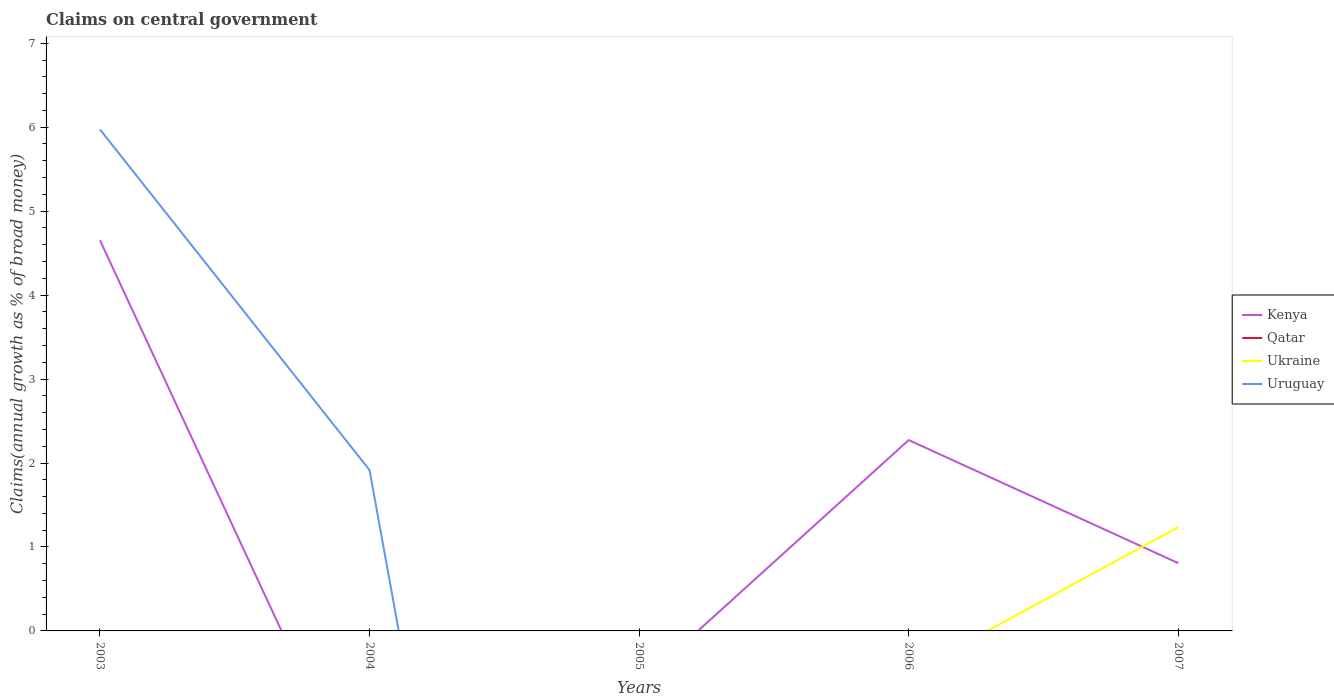How many different coloured lines are there?
Ensure brevity in your answer.  3. Does the line corresponding to Uruguay intersect with the line corresponding to Kenya?
Offer a very short reply. Yes. What is the difference between the highest and the second highest percentage of broad money claimed on centeral government in Uruguay?
Offer a very short reply. 5.97. Is the percentage of broad money claimed on centeral government in Ukraine strictly greater than the percentage of broad money claimed on centeral government in Qatar over the years?
Give a very brief answer. No. Are the values on the major ticks of Y-axis written in scientific E-notation?
Your response must be concise. No. Does the graph contain grids?
Your response must be concise. No. How many legend labels are there?
Your response must be concise. 4. What is the title of the graph?
Keep it short and to the point. Claims on central government. What is the label or title of the X-axis?
Provide a succinct answer. Years. What is the label or title of the Y-axis?
Offer a terse response. Claims(annual growth as % of broad money). What is the Claims(annual growth as % of broad money) in Kenya in 2003?
Make the answer very short. 4.65. What is the Claims(annual growth as % of broad money) of Uruguay in 2003?
Your answer should be compact. 5.97. What is the Claims(annual growth as % of broad money) in Ukraine in 2004?
Ensure brevity in your answer.  0. What is the Claims(annual growth as % of broad money) in Uruguay in 2004?
Give a very brief answer. 1.92. What is the Claims(annual growth as % of broad money) of Kenya in 2005?
Provide a short and direct response. 0. What is the Claims(annual growth as % of broad money) of Qatar in 2005?
Your response must be concise. 0. What is the Claims(annual growth as % of broad money) in Kenya in 2006?
Offer a very short reply. 2.27. What is the Claims(annual growth as % of broad money) in Kenya in 2007?
Your answer should be compact. 0.81. What is the Claims(annual growth as % of broad money) in Ukraine in 2007?
Make the answer very short. 1.24. What is the Claims(annual growth as % of broad money) in Uruguay in 2007?
Provide a short and direct response. 0. Across all years, what is the maximum Claims(annual growth as % of broad money) in Kenya?
Your answer should be compact. 4.65. Across all years, what is the maximum Claims(annual growth as % of broad money) in Ukraine?
Make the answer very short. 1.24. Across all years, what is the maximum Claims(annual growth as % of broad money) in Uruguay?
Your answer should be very brief. 5.97. Across all years, what is the minimum Claims(annual growth as % of broad money) in Kenya?
Offer a terse response. 0. Across all years, what is the minimum Claims(annual growth as % of broad money) of Ukraine?
Offer a terse response. 0. What is the total Claims(annual growth as % of broad money) in Kenya in the graph?
Offer a very short reply. 7.73. What is the total Claims(annual growth as % of broad money) in Qatar in the graph?
Your answer should be compact. 0. What is the total Claims(annual growth as % of broad money) in Ukraine in the graph?
Ensure brevity in your answer.  1.24. What is the total Claims(annual growth as % of broad money) of Uruguay in the graph?
Keep it short and to the point. 7.89. What is the difference between the Claims(annual growth as % of broad money) in Uruguay in 2003 and that in 2004?
Provide a short and direct response. 4.06. What is the difference between the Claims(annual growth as % of broad money) in Kenya in 2003 and that in 2006?
Give a very brief answer. 2.38. What is the difference between the Claims(annual growth as % of broad money) in Kenya in 2003 and that in 2007?
Give a very brief answer. 3.85. What is the difference between the Claims(annual growth as % of broad money) in Kenya in 2006 and that in 2007?
Provide a succinct answer. 1.47. What is the difference between the Claims(annual growth as % of broad money) of Kenya in 2003 and the Claims(annual growth as % of broad money) of Uruguay in 2004?
Make the answer very short. 2.74. What is the difference between the Claims(annual growth as % of broad money) in Kenya in 2003 and the Claims(annual growth as % of broad money) in Ukraine in 2007?
Ensure brevity in your answer.  3.42. What is the difference between the Claims(annual growth as % of broad money) in Kenya in 2006 and the Claims(annual growth as % of broad money) in Ukraine in 2007?
Your answer should be compact. 1.04. What is the average Claims(annual growth as % of broad money) of Kenya per year?
Your response must be concise. 1.55. What is the average Claims(annual growth as % of broad money) of Ukraine per year?
Offer a very short reply. 0.25. What is the average Claims(annual growth as % of broad money) in Uruguay per year?
Your answer should be very brief. 1.58. In the year 2003, what is the difference between the Claims(annual growth as % of broad money) in Kenya and Claims(annual growth as % of broad money) in Uruguay?
Give a very brief answer. -1.32. In the year 2007, what is the difference between the Claims(annual growth as % of broad money) in Kenya and Claims(annual growth as % of broad money) in Ukraine?
Offer a terse response. -0.43. What is the ratio of the Claims(annual growth as % of broad money) of Uruguay in 2003 to that in 2004?
Provide a short and direct response. 3.12. What is the ratio of the Claims(annual growth as % of broad money) of Kenya in 2003 to that in 2006?
Your response must be concise. 2.05. What is the ratio of the Claims(annual growth as % of broad money) in Kenya in 2003 to that in 2007?
Your response must be concise. 5.77. What is the ratio of the Claims(annual growth as % of broad money) in Kenya in 2006 to that in 2007?
Ensure brevity in your answer.  2.82. What is the difference between the highest and the second highest Claims(annual growth as % of broad money) in Kenya?
Give a very brief answer. 2.38. What is the difference between the highest and the lowest Claims(annual growth as % of broad money) of Kenya?
Keep it short and to the point. 4.65. What is the difference between the highest and the lowest Claims(annual growth as % of broad money) of Ukraine?
Give a very brief answer. 1.24. What is the difference between the highest and the lowest Claims(annual growth as % of broad money) in Uruguay?
Your answer should be very brief. 5.97. 